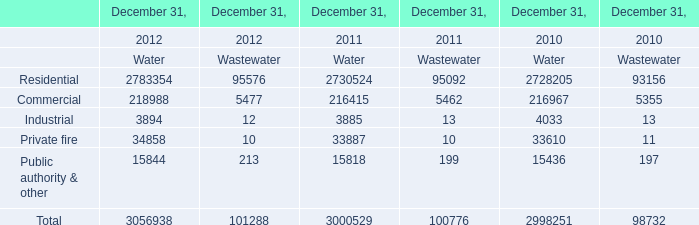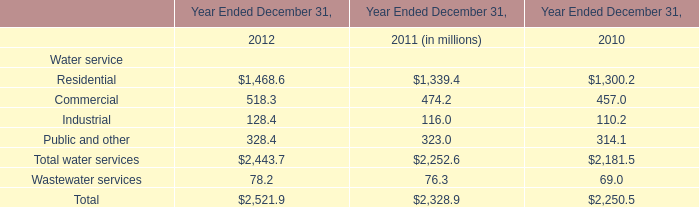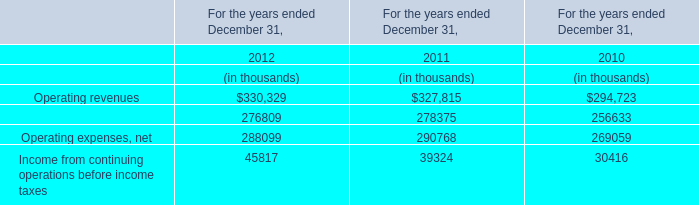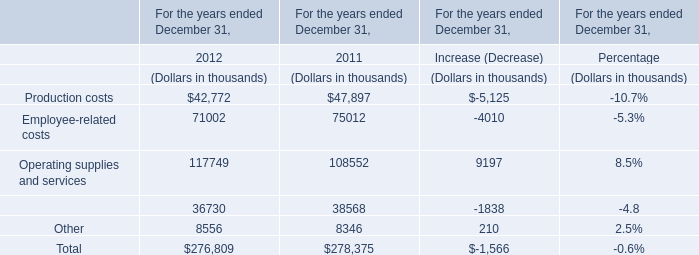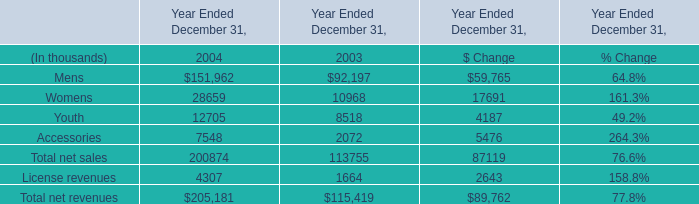If employee-related costsdevelops with the same growth rate in 2012, what will it reach in 2013? (in thousand) 
Computations: ((((71002 - 75012) / 75012) + 1) * 71002)
Answer: 67206.36703. 